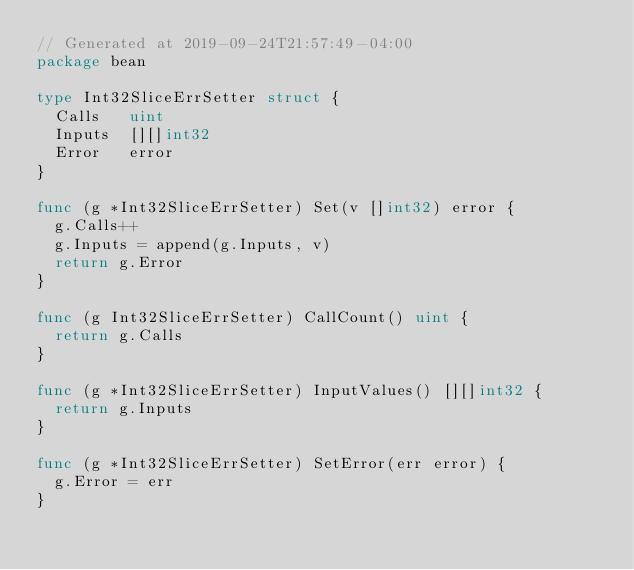<code> <loc_0><loc_0><loc_500><loc_500><_Go_>// Generated at 2019-09-24T21:57:49-04:00
package bean

type Int32SliceErrSetter struct {
	Calls   uint
	Inputs  [][]int32
	Error   error
}

func (g *Int32SliceErrSetter) Set(v []int32) error {
	g.Calls++
	g.Inputs = append(g.Inputs, v)
	return g.Error
}

func (g Int32SliceErrSetter) CallCount() uint {
	return g.Calls
}

func (g *Int32SliceErrSetter) InputValues() [][]int32 {
	return g.Inputs
}

func (g *Int32SliceErrSetter) SetError(err error) {
	g.Error = err
}
</code> 